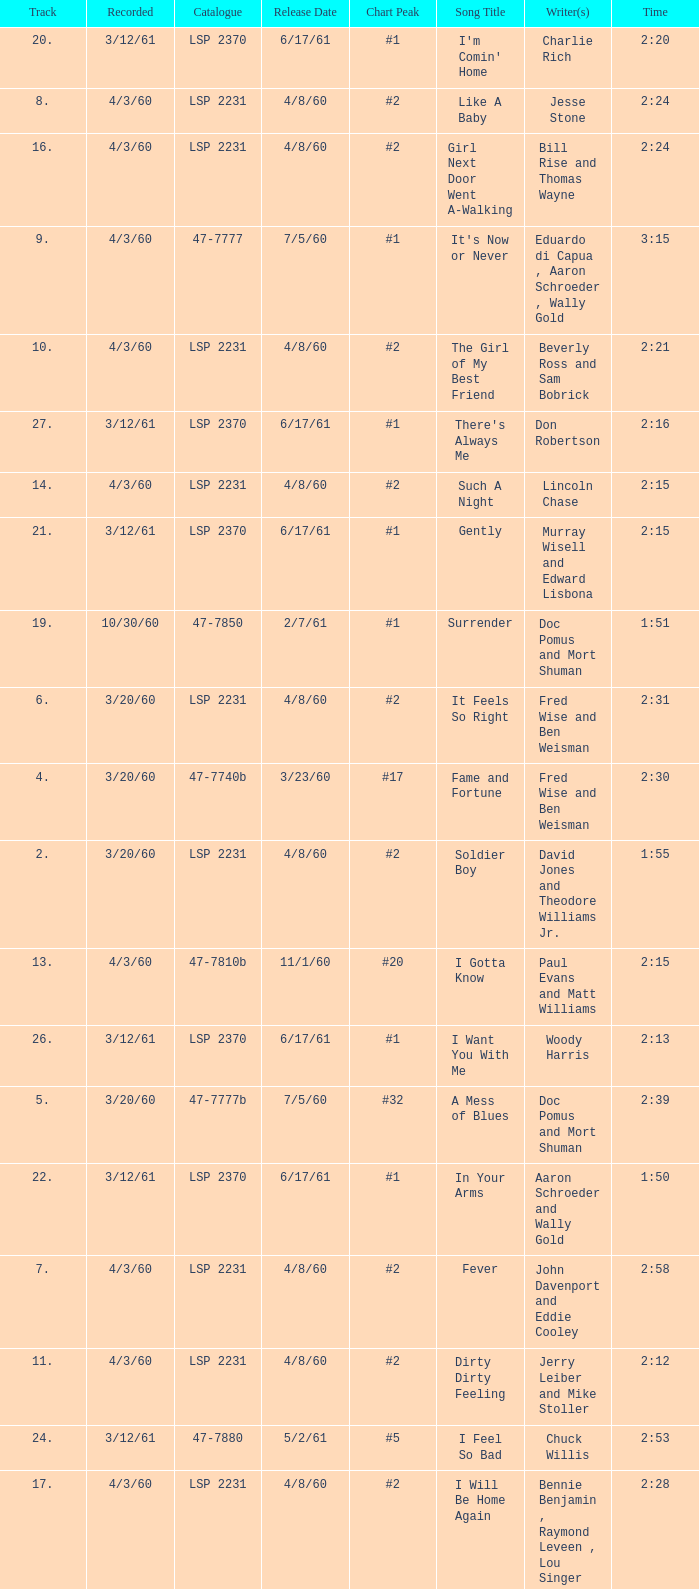What catalogue is the song It's Now or Never? 47-7777. 